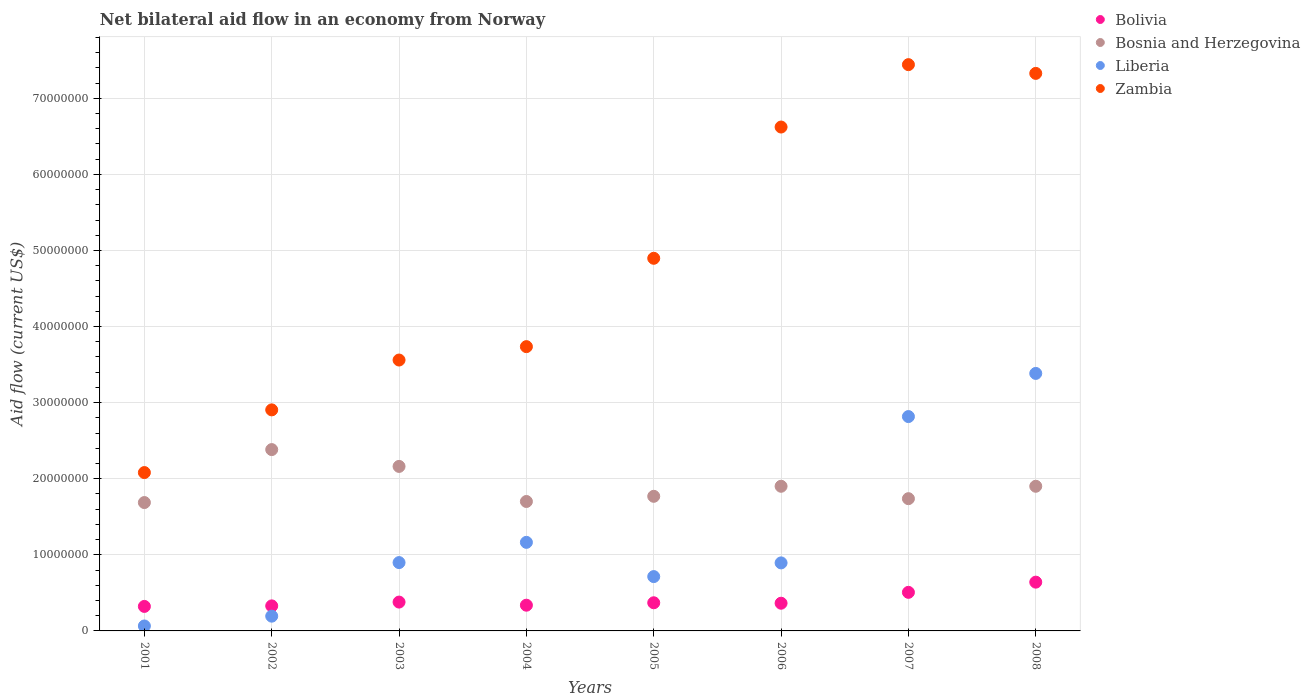Is the number of dotlines equal to the number of legend labels?
Your response must be concise. Yes. What is the net bilateral aid flow in Bolivia in 2003?
Provide a succinct answer. 3.79e+06. Across all years, what is the maximum net bilateral aid flow in Zambia?
Ensure brevity in your answer.  7.44e+07. Across all years, what is the minimum net bilateral aid flow in Bosnia and Herzegovina?
Provide a succinct answer. 1.69e+07. In which year was the net bilateral aid flow in Zambia maximum?
Offer a terse response. 2007. What is the total net bilateral aid flow in Bolivia in the graph?
Make the answer very short. 3.25e+07. What is the difference between the net bilateral aid flow in Bolivia in 2001 and that in 2008?
Provide a short and direct response. -3.19e+06. What is the difference between the net bilateral aid flow in Zambia in 2006 and the net bilateral aid flow in Bolivia in 2005?
Your response must be concise. 6.25e+07. What is the average net bilateral aid flow in Bosnia and Herzegovina per year?
Offer a very short reply. 1.91e+07. In the year 2003, what is the difference between the net bilateral aid flow in Bosnia and Herzegovina and net bilateral aid flow in Zambia?
Ensure brevity in your answer.  -1.40e+07. What is the ratio of the net bilateral aid flow in Zambia in 2001 to that in 2006?
Your answer should be compact. 0.31. Is the difference between the net bilateral aid flow in Bosnia and Herzegovina in 2001 and 2005 greater than the difference between the net bilateral aid flow in Zambia in 2001 and 2005?
Offer a terse response. Yes. What is the difference between the highest and the second highest net bilateral aid flow in Liberia?
Your response must be concise. 5.67e+06. What is the difference between the highest and the lowest net bilateral aid flow in Zambia?
Your response must be concise. 5.36e+07. In how many years, is the net bilateral aid flow in Bosnia and Herzegovina greater than the average net bilateral aid flow in Bosnia and Herzegovina taken over all years?
Keep it short and to the point. 2. Is it the case that in every year, the sum of the net bilateral aid flow in Zambia and net bilateral aid flow in Bolivia  is greater than the sum of net bilateral aid flow in Bosnia and Herzegovina and net bilateral aid flow in Liberia?
Your answer should be very brief. No. Is the net bilateral aid flow in Bosnia and Herzegovina strictly less than the net bilateral aid flow in Zambia over the years?
Ensure brevity in your answer.  Yes. Does the graph contain any zero values?
Provide a short and direct response. No. Where does the legend appear in the graph?
Provide a succinct answer. Top right. What is the title of the graph?
Provide a succinct answer. Net bilateral aid flow in an economy from Norway. Does "Congo (Democratic)" appear as one of the legend labels in the graph?
Provide a succinct answer. No. What is the label or title of the Y-axis?
Keep it short and to the point. Aid flow (current US$). What is the Aid flow (current US$) in Bolivia in 2001?
Give a very brief answer. 3.22e+06. What is the Aid flow (current US$) of Bosnia and Herzegovina in 2001?
Make the answer very short. 1.69e+07. What is the Aid flow (current US$) in Liberia in 2001?
Offer a very short reply. 6.50e+05. What is the Aid flow (current US$) in Zambia in 2001?
Give a very brief answer. 2.08e+07. What is the Aid flow (current US$) in Bolivia in 2002?
Make the answer very short. 3.29e+06. What is the Aid flow (current US$) in Bosnia and Herzegovina in 2002?
Make the answer very short. 2.38e+07. What is the Aid flow (current US$) of Liberia in 2002?
Your answer should be compact. 1.94e+06. What is the Aid flow (current US$) of Zambia in 2002?
Your answer should be compact. 2.90e+07. What is the Aid flow (current US$) of Bolivia in 2003?
Your answer should be very brief. 3.79e+06. What is the Aid flow (current US$) of Bosnia and Herzegovina in 2003?
Ensure brevity in your answer.  2.16e+07. What is the Aid flow (current US$) of Liberia in 2003?
Ensure brevity in your answer.  8.98e+06. What is the Aid flow (current US$) in Zambia in 2003?
Your response must be concise. 3.56e+07. What is the Aid flow (current US$) of Bolivia in 2004?
Your response must be concise. 3.38e+06. What is the Aid flow (current US$) in Bosnia and Herzegovina in 2004?
Your answer should be compact. 1.70e+07. What is the Aid flow (current US$) in Liberia in 2004?
Keep it short and to the point. 1.16e+07. What is the Aid flow (current US$) in Zambia in 2004?
Offer a very short reply. 3.74e+07. What is the Aid flow (current US$) in Bolivia in 2005?
Give a very brief answer. 3.70e+06. What is the Aid flow (current US$) in Bosnia and Herzegovina in 2005?
Keep it short and to the point. 1.77e+07. What is the Aid flow (current US$) of Liberia in 2005?
Give a very brief answer. 7.14e+06. What is the Aid flow (current US$) in Zambia in 2005?
Give a very brief answer. 4.90e+07. What is the Aid flow (current US$) of Bolivia in 2006?
Keep it short and to the point. 3.64e+06. What is the Aid flow (current US$) in Bosnia and Herzegovina in 2006?
Keep it short and to the point. 1.90e+07. What is the Aid flow (current US$) in Liberia in 2006?
Your response must be concise. 8.94e+06. What is the Aid flow (current US$) of Zambia in 2006?
Make the answer very short. 6.62e+07. What is the Aid flow (current US$) in Bolivia in 2007?
Keep it short and to the point. 5.07e+06. What is the Aid flow (current US$) in Bosnia and Herzegovina in 2007?
Your answer should be compact. 1.74e+07. What is the Aid flow (current US$) of Liberia in 2007?
Your answer should be compact. 2.82e+07. What is the Aid flow (current US$) of Zambia in 2007?
Ensure brevity in your answer.  7.44e+07. What is the Aid flow (current US$) of Bolivia in 2008?
Your response must be concise. 6.41e+06. What is the Aid flow (current US$) in Bosnia and Herzegovina in 2008?
Provide a short and direct response. 1.90e+07. What is the Aid flow (current US$) of Liberia in 2008?
Your answer should be compact. 3.38e+07. What is the Aid flow (current US$) of Zambia in 2008?
Offer a terse response. 7.33e+07. Across all years, what is the maximum Aid flow (current US$) in Bolivia?
Provide a short and direct response. 6.41e+06. Across all years, what is the maximum Aid flow (current US$) in Bosnia and Herzegovina?
Provide a short and direct response. 2.38e+07. Across all years, what is the maximum Aid flow (current US$) of Liberia?
Ensure brevity in your answer.  3.38e+07. Across all years, what is the maximum Aid flow (current US$) of Zambia?
Your answer should be very brief. 7.44e+07. Across all years, what is the minimum Aid flow (current US$) in Bolivia?
Your response must be concise. 3.22e+06. Across all years, what is the minimum Aid flow (current US$) in Bosnia and Herzegovina?
Your answer should be very brief. 1.69e+07. Across all years, what is the minimum Aid flow (current US$) of Liberia?
Provide a short and direct response. 6.50e+05. Across all years, what is the minimum Aid flow (current US$) of Zambia?
Provide a succinct answer. 2.08e+07. What is the total Aid flow (current US$) of Bolivia in the graph?
Keep it short and to the point. 3.25e+07. What is the total Aid flow (current US$) in Bosnia and Herzegovina in the graph?
Your answer should be very brief. 1.52e+08. What is the total Aid flow (current US$) of Liberia in the graph?
Your answer should be compact. 1.01e+08. What is the total Aid flow (current US$) of Zambia in the graph?
Give a very brief answer. 3.86e+08. What is the difference between the Aid flow (current US$) of Bolivia in 2001 and that in 2002?
Provide a short and direct response. -7.00e+04. What is the difference between the Aid flow (current US$) of Bosnia and Herzegovina in 2001 and that in 2002?
Keep it short and to the point. -6.96e+06. What is the difference between the Aid flow (current US$) of Liberia in 2001 and that in 2002?
Ensure brevity in your answer.  -1.29e+06. What is the difference between the Aid flow (current US$) in Zambia in 2001 and that in 2002?
Make the answer very short. -8.24e+06. What is the difference between the Aid flow (current US$) of Bolivia in 2001 and that in 2003?
Keep it short and to the point. -5.70e+05. What is the difference between the Aid flow (current US$) in Bosnia and Herzegovina in 2001 and that in 2003?
Your answer should be compact. -4.75e+06. What is the difference between the Aid flow (current US$) in Liberia in 2001 and that in 2003?
Provide a short and direct response. -8.33e+06. What is the difference between the Aid flow (current US$) in Zambia in 2001 and that in 2003?
Your response must be concise. -1.48e+07. What is the difference between the Aid flow (current US$) in Bosnia and Herzegovina in 2001 and that in 2004?
Make the answer very short. -1.40e+05. What is the difference between the Aid flow (current US$) of Liberia in 2001 and that in 2004?
Your answer should be compact. -1.10e+07. What is the difference between the Aid flow (current US$) of Zambia in 2001 and that in 2004?
Your answer should be very brief. -1.66e+07. What is the difference between the Aid flow (current US$) of Bolivia in 2001 and that in 2005?
Offer a very short reply. -4.80e+05. What is the difference between the Aid flow (current US$) of Bosnia and Herzegovina in 2001 and that in 2005?
Your answer should be compact. -8.20e+05. What is the difference between the Aid flow (current US$) in Liberia in 2001 and that in 2005?
Your response must be concise. -6.49e+06. What is the difference between the Aid flow (current US$) of Zambia in 2001 and that in 2005?
Give a very brief answer. -2.82e+07. What is the difference between the Aid flow (current US$) of Bolivia in 2001 and that in 2006?
Your answer should be very brief. -4.20e+05. What is the difference between the Aid flow (current US$) in Bosnia and Herzegovina in 2001 and that in 2006?
Your response must be concise. -2.14e+06. What is the difference between the Aid flow (current US$) in Liberia in 2001 and that in 2006?
Offer a very short reply. -8.29e+06. What is the difference between the Aid flow (current US$) in Zambia in 2001 and that in 2006?
Your answer should be compact. -4.54e+07. What is the difference between the Aid flow (current US$) of Bolivia in 2001 and that in 2007?
Your answer should be compact. -1.85e+06. What is the difference between the Aid flow (current US$) of Bosnia and Herzegovina in 2001 and that in 2007?
Offer a terse response. -5.10e+05. What is the difference between the Aid flow (current US$) of Liberia in 2001 and that in 2007?
Your answer should be very brief. -2.75e+07. What is the difference between the Aid flow (current US$) of Zambia in 2001 and that in 2007?
Offer a terse response. -5.36e+07. What is the difference between the Aid flow (current US$) of Bolivia in 2001 and that in 2008?
Offer a very short reply. -3.19e+06. What is the difference between the Aid flow (current US$) in Bosnia and Herzegovina in 2001 and that in 2008?
Your answer should be very brief. -2.14e+06. What is the difference between the Aid flow (current US$) of Liberia in 2001 and that in 2008?
Provide a short and direct response. -3.32e+07. What is the difference between the Aid flow (current US$) in Zambia in 2001 and that in 2008?
Make the answer very short. -5.25e+07. What is the difference between the Aid flow (current US$) in Bolivia in 2002 and that in 2003?
Keep it short and to the point. -5.00e+05. What is the difference between the Aid flow (current US$) in Bosnia and Herzegovina in 2002 and that in 2003?
Give a very brief answer. 2.21e+06. What is the difference between the Aid flow (current US$) in Liberia in 2002 and that in 2003?
Your answer should be compact. -7.04e+06. What is the difference between the Aid flow (current US$) in Zambia in 2002 and that in 2003?
Ensure brevity in your answer.  -6.55e+06. What is the difference between the Aid flow (current US$) in Bolivia in 2002 and that in 2004?
Give a very brief answer. -9.00e+04. What is the difference between the Aid flow (current US$) of Bosnia and Herzegovina in 2002 and that in 2004?
Provide a succinct answer. 6.82e+06. What is the difference between the Aid flow (current US$) in Liberia in 2002 and that in 2004?
Provide a short and direct response. -9.70e+06. What is the difference between the Aid flow (current US$) in Zambia in 2002 and that in 2004?
Give a very brief answer. -8.31e+06. What is the difference between the Aid flow (current US$) in Bolivia in 2002 and that in 2005?
Provide a succinct answer. -4.10e+05. What is the difference between the Aid flow (current US$) in Bosnia and Herzegovina in 2002 and that in 2005?
Give a very brief answer. 6.14e+06. What is the difference between the Aid flow (current US$) in Liberia in 2002 and that in 2005?
Ensure brevity in your answer.  -5.20e+06. What is the difference between the Aid flow (current US$) in Zambia in 2002 and that in 2005?
Make the answer very short. -1.99e+07. What is the difference between the Aid flow (current US$) in Bolivia in 2002 and that in 2006?
Give a very brief answer. -3.50e+05. What is the difference between the Aid flow (current US$) in Bosnia and Herzegovina in 2002 and that in 2006?
Offer a terse response. 4.82e+06. What is the difference between the Aid flow (current US$) in Liberia in 2002 and that in 2006?
Keep it short and to the point. -7.00e+06. What is the difference between the Aid flow (current US$) of Zambia in 2002 and that in 2006?
Give a very brief answer. -3.72e+07. What is the difference between the Aid flow (current US$) of Bolivia in 2002 and that in 2007?
Offer a very short reply. -1.78e+06. What is the difference between the Aid flow (current US$) in Bosnia and Herzegovina in 2002 and that in 2007?
Provide a succinct answer. 6.45e+06. What is the difference between the Aid flow (current US$) of Liberia in 2002 and that in 2007?
Offer a very short reply. -2.62e+07. What is the difference between the Aid flow (current US$) of Zambia in 2002 and that in 2007?
Your response must be concise. -4.54e+07. What is the difference between the Aid flow (current US$) of Bolivia in 2002 and that in 2008?
Ensure brevity in your answer.  -3.12e+06. What is the difference between the Aid flow (current US$) in Bosnia and Herzegovina in 2002 and that in 2008?
Offer a very short reply. 4.82e+06. What is the difference between the Aid flow (current US$) of Liberia in 2002 and that in 2008?
Give a very brief answer. -3.19e+07. What is the difference between the Aid flow (current US$) in Zambia in 2002 and that in 2008?
Provide a short and direct response. -4.42e+07. What is the difference between the Aid flow (current US$) of Bosnia and Herzegovina in 2003 and that in 2004?
Ensure brevity in your answer.  4.61e+06. What is the difference between the Aid flow (current US$) in Liberia in 2003 and that in 2004?
Make the answer very short. -2.66e+06. What is the difference between the Aid flow (current US$) in Zambia in 2003 and that in 2004?
Keep it short and to the point. -1.76e+06. What is the difference between the Aid flow (current US$) of Bosnia and Herzegovina in 2003 and that in 2005?
Give a very brief answer. 3.93e+06. What is the difference between the Aid flow (current US$) in Liberia in 2003 and that in 2005?
Provide a short and direct response. 1.84e+06. What is the difference between the Aid flow (current US$) in Zambia in 2003 and that in 2005?
Make the answer very short. -1.34e+07. What is the difference between the Aid flow (current US$) of Bolivia in 2003 and that in 2006?
Make the answer very short. 1.50e+05. What is the difference between the Aid flow (current US$) of Bosnia and Herzegovina in 2003 and that in 2006?
Offer a terse response. 2.61e+06. What is the difference between the Aid flow (current US$) of Liberia in 2003 and that in 2006?
Your answer should be very brief. 4.00e+04. What is the difference between the Aid flow (current US$) of Zambia in 2003 and that in 2006?
Keep it short and to the point. -3.06e+07. What is the difference between the Aid flow (current US$) in Bolivia in 2003 and that in 2007?
Make the answer very short. -1.28e+06. What is the difference between the Aid flow (current US$) of Bosnia and Herzegovina in 2003 and that in 2007?
Make the answer very short. 4.24e+06. What is the difference between the Aid flow (current US$) in Liberia in 2003 and that in 2007?
Provide a short and direct response. -1.92e+07. What is the difference between the Aid flow (current US$) of Zambia in 2003 and that in 2007?
Give a very brief answer. -3.88e+07. What is the difference between the Aid flow (current US$) in Bolivia in 2003 and that in 2008?
Make the answer very short. -2.62e+06. What is the difference between the Aid flow (current US$) in Bosnia and Herzegovina in 2003 and that in 2008?
Provide a short and direct response. 2.61e+06. What is the difference between the Aid flow (current US$) of Liberia in 2003 and that in 2008?
Provide a succinct answer. -2.49e+07. What is the difference between the Aid flow (current US$) in Zambia in 2003 and that in 2008?
Provide a short and direct response. -3.77e+07. What is the difference between the Aid flow (current US$) of Bolivia in 2004 and that in 2005?
Your answer should be very brief. -3.20e+05. What is the difference between the Aid flow (current US$) in Bosnia and Herzegovina in 2004 and that in 2005?
Your answer should be very brief. -6.80e+05. What is the difference between the Aid flow (current US$) of Liberia in 2004 and that in 2005?
Give a very brief answer. 4.50e+06. What is the difference between the Aid flow (current US$) in Zambia in 2004 and that in 2005?
Provide a succinct answer. -1.16e+07. What is the difference between the Aid flow (current US$) in Bolivia in 2004 and that in 2006?
Provide a short and direct response. -2.60e+05. What is the difference between the Aid flow (current US$) of Liberia in 2004 and that in 2006?
Keep it short and to the point. 2.70e+06. What is the difference between the Aid flow (current US$) of Zambia in 2004 and that in 2006?
Your response must be concise. -2.89e+07. What is the difference between the Aid flow (current US$) of Bolivia in 2004 and that in 2007?
Give a very brief answer. -1.69e+06. What is the difference between the Aid flow (current US$) of Bosnia and Herzegovina in 2004 and that in 2007?
Your response must be concise. -3.70e+05. What is the difference between the Aid flow (current US$) in Liberia in 2004 and that in 2007?
Offer a very short reply. -1.65e+07. What is the difference between the Aid flow (current US$) of Zambia in 2004 and that in 2007?
Provide a short and direct response. -3.71e+07. What is the difference between the Aid flow (current US$) in Bolivia in 2004 and that in 2008?
Your answer should be very brief. -3.03e+06. What is the difference between the Aid flow (current US$) in Bosnia and Herzegovina in 2004 and that in 2008?
Make the answer very short. -2.00e+06. What is the difference between the Aid flow (current US$) of Liberia in 2004 and that in 2008?
Provide a short and direct response. -2.22e+07. What is the difference between the Aid flow (current US$) in Zambia in 2004 and that in 2008?
Offer a terse response. -3.59e+07. What is the difference between the Aid flow (current US$) of Bosnia and Herzegovina in 2005 and that in 2006?
Offer a terse response. -1.32e+06. What is the difference between the Aid flow (current US$) of Liberia in 2005 and that in 2006?
Give a very brief answer. -1.80e+06. What is the difference between the Aid flow (current US$) in Zambia in 2005 and that in 2006?
Your response must be concise. -1.72e+07. What is the difference between the Aid flow (current US$) of Bolivia in 2005 and that in 2007?
Your response must be concise. -1.37e+06. What is the difference between the Aid flow (current US$) in Liberia in 2005 and that in 2007?
Make the answer very short. -2.10e+07. What is the difference between the Aid flow (current US$) of Zambia in 2005 and that in 2007?
Your response must be concise. -2.54e+07. What is the difference between the Aid flow (current US$) of Bolivia in 2005 and that in 2008?
Offer a terse response. -2.71e+06. What is the difference between the Aid flow (current US$) of Bosnia and Herzegovina in 2005 and that in 2008?
Your response must be concise. -1.32e+06. What is the difference between the Aid flow (current US$) of Liberia in 2005 and that in 2008?
Give a very brief answer. -2.67e+07. What is the difference between the Aid flow (current US$) in Zambia in 2005 and that in 2008?
Keep it short and to the point. -2.43e+07. What is the difference between the Aid flow (current US$) of Bolivia in 2006 and that in 2007?
Keep it short and to the point. -1.43e+06. What is the difference between the Aid flow (current US$) in Bosnia and Herzegovina in 2006 and that in 2007?
Offer a very short reply. 1.63e+06. What is the difference between the Aid flow (current US$) in Liberia in 2006 and that in 2007?
Provide a short and direct response. -1.92e+07. What is the difference between the Aid flow (current US$) in Zambia in 2006 and that in 2007?
Make the answer very short. -8.20e+06. What is the difference between the Aid flow (current US$) in Bolivia in 2006 and that in 2008?
Your answer should be compact. -2.77e+06. What is the difference between the Aid flow (current US$) in Liberia in 2006 and that in 2008?
Keep it short and to the point. -2.49e+07. What is the difference between the Aid flow (current US$) of Zambia in 2006 and that in 2008?
Offer a very short reply. -7.05e+06. What is the difference between the Aid flow (current US$) in Bolivia in 2007 and that in 2008?
Provide a succinct answer. -1.34e+06. What is the difference between the Aid flow (current US$) in Bosnia and Herzegovina in 2007 and that in 2008?
Make the answer very short. -1.63e+06. What is the difference between the Aid flow (current US$) of Liberia in 2007 and that in 2008?
Offer a very short reply. -5.67e+06. What is the difference between the Aid flow (current US$) in Zambia in 2007 and that in 2008?
Give a very brief answer. 1.15e+06. What is the difference between the Aid flow (current US$) of Bolivia in 2001 and the Aid flow (current US$) of Bosnia and Herzegovina in 2002?
Offer a very short reply. -2.06e+07. What is the difference between the Aid flow (current US$) of Bolivia in 2001 and the Aid flow (current US$) of Liberia in 2002?
Your answer should be very brief. 1.28e+06. What is the difference between the Aid flow (current US$) of Bolivia in 2001 and the Aid flow (current US$) of Zambia in 2002?
Provide a succinct answer. -2.58e+07. What is the difference between the Aid flow (current US$) in Bosnia and Herzegovina in 2001 and the Aid flow (current US$) in Liberia in 2002?
Provide a short and direct response. 1.49e+07. What is the difference between the Aid flow (current US$) of Bosnia and Herzegovina in 2001 and the Aid flow (current US$) of Zambia in 2002?
Provide a succinct answer. -1.22e+07. What is the difference between the Aid flow (current US$) in Liberia in 2001 and the Aid flow (current US$) in Zambia in 2002?
Offer a very short reply. -2.84e+07. What is the difference between the Aid flow (current US$) in Bolivia in 2001 and the Aid flow (current US$) in Bosnia and Herzegovina in 2003?
Keep it short and to the point. -1.84e+07. What is the difference between the Aid flow (current US$) in Bolivia in 2001 and the Aid flow (current US$) in Liberia in 2003?
Ensure brevity in your answer.  -5.76e+06. What is the difference between the Aid flow (current US$) of Bolivia in 2001 and the Aid flow (current US$) of Zambia in 2003?
Your answer should be compact. -3.24e+07. What is the difference between the Aid flow (current US$) in Bosnia and Herzegovina in 2001 and the Aid flow (current US$) in Liberia in 2003?
Keep it short and to the point. 7.89e+06. What is the difference between the Aid flow (current US$) of Bosnia and Herzegovina in 2001 and the Aid flow (current US$) of Zambia in 2003?
Make the answer very short. -1.87e+07. What is the difference between the Aid flow (current US$) in Liberia in 2001 and the Aid flow (current US$) in Zambia in 2003?
Provide a short and direct response. -3.50e+07. What is the difference between the Aid flow (current US$) of Bolivia in 2001 and the Aid flow (current US$) of Bosnia and Herzegovina in 2004?
Provide a succinct answer. -1.38e+07. What is the difference between the Aid flow (current US$) of Bolivia in 2001 and the Aid flow (current US$) of Liberia in 2004?
Your answer should be very brief. -8.42e+06. What is the difference between the Aid flow (current US$) in Bolivia in 2001 and the Aid flow (current US$) in Zambia in 2004?
Make the answer very short. -3.41e+07. What is the difference between the Aid flow (current US$) in Bosnia and Herzegovina in 2001 and the Aid flow (current US$) in Liberia in 2004?
Offer a terse response. 5.23e+06. What is the difference between the Aid flow (current US$) of Bosnia and Herzegovina in 2001 and the Aid flow (current US$) of Zambia in 2004?
Give a very brief answer. -2.05e+07. What is the difference between the Aid flow (current US$) in Liberia in 2001 and the Aid flow (current US$) in Zambia in 2004?
Your response must be concise. -3.67e+07. What is the difference between the Aid flow (current US$) in Bolivia in 2001 and the Aid flow (current US$) in Bosnia and Herzegovina in 2005?
Make the answer very short. -1.45e+07. What is the difference between the Aid flow (current US$) in Bolivia in 2001 and the Aid flow (current US$) in Liberia in 2005?
Provide a short and direct response. -3.92e+06. What is the difference between the Aid flow (current US$) of Bolivia in 2001 and the Aid flow (current US$) of Zambia in 2005?
Offer a terse response. -4.58e+07. What is the difference between the Aid flow (current US$) in Bosnia and Herzegovina in 2001 and the Aid flow (current US$) in Liberia in 2005?
Keep it short and to the point. 9.73e+06. What is the difference between the Aid flow (current US$) of Bosnia and Herzegovina in 2001 and the Aid flow (current US$) of Zambia in 2005?
Keep it short and to the point. -3.21e+07. What is the difference between the Aid flow (current US$) in Liberia in 2001 and the Aid flow (current US$) in Zambia in 2005?
Your answer should be compact. -4.83e+07. What is the difference between the Aid flow (current US$) in Bolivia in 2001 and the Aid flow (current US$) in Bosnia and Herzegovina in 2006?
Your answer should be compact. -1.58e+07. What is the difference between the Aid flow (current US$) in Bolivia in 2001 and the Aid flow (current US$) in Liberia in 2006?
Your response must be concise. -5.72e+06. What is the difference between the Aid flow (current US$) of Bolivia in 2001 and the Aid flow (current US$) of Zambia in 2006?
Your answer should be very brief. -6.30e+07. What is the difference between the Aid flow (current US$) of Bosnia and Herzegovina in 2001 and the Aid flow (current US$) of Liberia in 2006?
Offer a terse response. 7.93e+06. What is the difference between the Aid flow (current US$) of Bosnia and Herzegovina in 2001 and the Aid flow (current US$) of Zambia in 2006?
Offer a very short reply. -4.94e+07. What is the difference between the Aid flow (current US$) in Liberia in 2001 and the Aid flow (current US$) in Zambia in 2006?
Make the answer very short. -6.56e+07. What is the difference between the Aid flow (current US$) in Bolivia in 2001 and the Aid flow (current US$) in Bosnia and Herzegovina in 2007?
Your answer should be compact. -1.42e+07. What is the difference between the Aid flow (current US$) in Bolivia in 2001 and the Aid flow (current US$) in Liberia in 2007?
Offer a terse response. -2.50e+07. What is the difference between the Aid flow (current US$) in Bolivia in 2001 and the Aid flow (current US$) in Zambia in 2007?
Offer a terse response. -7.12e+07. What is the difference between the Aid flow (current US$) in Bosnia and Herzegovina in 2001 and the Aid flow (current US$) in Liberia in 2007?
Your response must be concise. -1.13e+07. What is the difference between the Aid flow (current US$) in Bosnia and Herzegovina in 2001 and the Aid flow (current US$) in Zambia in 2007?
Make the answer very short. -5.76e+07. What is the difference between the Aid flow (current US$) in Liberia in 2001 and the Aid flow (current US$) in Zambia in 2007?
Keep it short and to the point. -7.38e+07. What is the difference between the Aid flow (current US$) in Bolivia in 2001 and the Aid flow (current US$) in Bosnia and Herzegovina in 2008?
Provide a succinct answer. -1.58e+07. What is the difference between the Aid flow (current US$) of Bolivia in 2001 and the Aid flow (current US$) of Liberia in 2008?
Provide a short and direct response. -3.06e+07. What is the difference between the Aid flow (current US$) of Bolivia in 2001 and the Aid flow (current US$) of Zambia in 2008?
Offer a very short reply. -7.00e+07. What is the difference between the Aid flow (current US$) in Bosnia and Herzegovina in 2001 and the Aid flow (current US$) in Liberia in 2008?
Provide a short and direct response. -1.70e+07. What is the difference between the Aid flow (current US$) of Bosnia and Herzegovina in 2001 and the Aid flow (current US$) of Zambia in 2008?
Ensure brevity in your answer.  -5.64e+07. What is the difference between the Aid flow (current US$) of Liberia in 2001 and the Aid flow (current US$) of Zambia in 2008?
Your response must be concise. -7.26e+07. What is the difference between the Aid flow (current US$) of Bolivia in 2002 and the Aid flow (current US$) of Bosnia and Herzegovina in 2003?
Ensure brevity in your answer.  -1.83e+07. What is the difference between the Aid flow (current US$) in Bolivia in 2002 and the Aid flow (current US$) in Liberia in 2003?
Give a very brief answer. -5.69e+06. What is the difference between the Aid flow (current US$) in Bolivia in 2002 and the Aid flow (current US$) in Zambia in 2003?
Offer a terse response. -3.23e+07. What is the difference between the Aid flow (current US$) of Bosnia and Herzegovina in 2002 and the Aid flow (current US$) of Liberia in 2003?
Your answer should be very brief. 1.48e+07. What is the difference between the Aid flow (current US$) of Bosnia and Herzegovina in 2002 and the Aid flow (current US$) of Zambia in 2003?
Give a very brief answer. -1.18e+07. What is the difference between the Aid flow (current US$) of Liberia in 2002 and the Aid flow (current US$) of Zambia in 2003?
Give a very brief answer. -3.37e+07. What is the difference between the Aid flow (current US$) of Bolivia in 2002 and the Aid flow (current US$) of Bosnia and Herzegovina in 2004?
Your answer should be very brief. -1.37e+07. What is the difference between the Aid flow (current US$) of Bolivia in 2002 and the Aid flow (current US$) of Liberia in 2004?
Ensure brevity in your answer.  -8.35e+06. What is the difference between the Aid flow (current US$) in Bolivia in 2002 and the Aid flow (current US$) in Zambia in 2004?
Offer a very short reply. -3.41e+07. What is the difference between the Aid flow (current US$) of Bosnia and Herzegovina in 2002 and the Aid flow (current US$) of Liberia in 2004?
Provide a succinct answer. 1.22e+07. What is the difference between the Aid flow (current US$) of Bosnia and Herzegovina in 2002 and the Aid flow (current US$) of Zambia in 2004?
Your answer should be very brief. -1.35e+07. What is the difference between the Aid flow (current US$) in Liberia in 2002 and the Aid flow (current US$) in Zambia in 2004?
Offer a terse response. -3.54e+07. What is the difference between the Aid flow (current US$) in Bolivia in 2002 and the Aid flow (current US$) in Bosnia and Herzegovina in 2005?
Ensure brevity in your answer.  -1.44e+07. What is the difference between the Aid flow (current US$) in Bolivia in 2002 and the Aid flow (current US$) in Liberia in 2005?
Your answer should be compact. -3.85e+06. What is the difference between the Aid flow (current US$) of Bolivia in 2002 and the Aid flow (current US$) of Zambia in 2005?
Make the answer very short. -4.57e+07. What is the difference between the Aid flow (current US$) in Bosnia and Herzegovina in 2002 and the Aid flow (current US$) in Liberia in 2005?
Your response must be concise. 1.67e+07. What is the difference between the Aid flow (current US$) in Bosnia and Herzegovina in 2002 and the Aid flow (current US$) in Zambia in 2005?
Ensure brevity in your answer.  -2.51e+07. What is the difference between the Aid flow (current US$) of Liberia in 2002 and the Aid flow (current US$) of Zambia in 2005?
Provide a succinct answer. -4.70e+07. What is the difference between the Aid flow (current US$) of Bolivia in 2002 and the Aid flow (current US$) of Bosnia and Herzegovina in 2006?
Your answer should be very brief. -1.57e+07. What is the difference between the Aid flow (current US$) of Bolivia in 2002 and the Aid flow (current US$) of Liberia in 2006?
Provide a short and direct response. -5.65e+06. What is the difference between the Aid flow (current US$) of Bolivia in 2002 and the Aid flow (current US$) of Zambia in 2006?
Give a very brief answer. -6.29e+07. What is the difference between the Aid flow (current US$) in Bosnia and Herzegovina in 2002 and the Aid flow (current US$) in Liberia in 2006?
Ensure brevity in your answer.  1.49e+07. What is the difference between the Aid flow (current US$) of Bosnia and Herzegovina in 2002 and the Aid flow (current US$) of Zambia in 2006?
Your answer should be very brief. -4.24e+07. What is the difference between the Aid flow (current US$) in Liberia in 2002 and the Aid flow (current US$) in Zambia in 2006?
Provide a short and direct response. -6.43e+07. What is the difference between the Aid flow (current US$) in Bolivia in 2002 and the Aid flow (current US$) in Bosnia and Herzegovina in 2007?
Your answer should be compact. -1.41e+07. What is the difference between the Aid flow (current US$) in Bolivia in 2002 and the Aid flow (current US$) in Liberia in 2007?
Your response must be concise. -2.49e+07. What is the difference between the Aid flow (current US$) of Bolivia in 2002 and the Aid flow (current US$) of Zambia in 2007?
Keep it short and to the point. -7.11e+07. What is the difference between the Aid flow (current US$) of Bosnia and Herzegovina in 2002 and the Aid flow (current US$) of Liberia in 2007?
Offer a very short reply. -4.34e+06. What is the difference between the Aid flow (current US$) of Bosnia and Herzegovina in 2002 and the Aid flow (current US$) of Zambia in 2007?
Keep it short and to the point. -5.06e+07. What is the difference between the Aid flow (current US$) of Liberia in 2002 and the Aid flow (current US$) of Zambia in 2007?
Provide a short and direct response. -7.25e+07. What is the difference between the Aid flow (current US$) in Bolivia in 2002 and the Aid flow (current US$) in Bosnia and Herzegovina in 2008?
Keep it short and to the point. -1.57e+07. What is the difference between the Aid flow (current US$) in Bolivia in 2002 and the Aid flow (current US$) in Liberia in 2008?
Your answer should be compact. -3.06e+07. What is the difference between the Aid flow (current US$) of Bolivia in 2002 and the Aid flow (current US$) of Zambia in 2008?
Give a very brief answer. -7.00e+07. What is the difference between the Aid flow (current US$) in Bosnia and Herzegovina in 2002 and the Aid flow (current US$) in Liberia in 2008?
Keep it short and to the point. -1.00e+07. What is the difference between the Aid flow (current US$) of Bosnia and Herzegovina in 2002 and the Aid flow (current US$) of Zambia in 2008?
Provide a short and direct response. -4.94e+07. What is the difference between the Aid flow (current US$) of Liberia in 2002 and the Aid flow (current US$) of Zambia in 2008?
Your response must be concise. -7.13e+07. What is the difference between the Aid flow (current US$) of Bolivia in 2003 and the Aid flow (current US$) of Bosnia and Herzegovina in 2004?
Your answer should be very brief. -1.32e+07. What is the difference between the Aid flow (current US$) in Bolivia in 2003 and the Aid flow (current US$) in Liberia in 2004?
Offer a very short reply. -7.85e+06. What is the difference between the Aid flow (current US$) of Bolivia in 2003 and the Aid flow (current US$) of Zambia in 2004?
Provide a succinct answer. -3.36e+07. What is the difference between the Aid flow (current US$) in Bosnia and Herzegovina in 2003 and the Aid flow (current US$) in Liberia in 2004?
Your answer should be very brief. 9.98e+06. What is the difference between the Aid flow (current US$) of Bosnia and Herzegovina in 2003 and the Aid flow (current US$) of Zambia in 2004?
Your answer should be very brief. -1.57e+07. What is the difference between the Aid flow (current US$) in Liberia in 2003 and the Aid flow (current US$) in Zambia in 2004?
Offer a terse response. -2.84e+07. What is the difference between the Aid flow (current US$) of Bolivia in 2003 and the Aid flow (current US$) of Bosnia and Herzegovina in 2005?
Offer a very short reply. -1.39e+07. What is the difference between the Aid flow (current US$) of Bolivia in 2003 and the Aid flow (current US$) of Liberia in 2005?
Your response must be concise. -3.35e+06. What is the difference between the Aid flow (current US$) of Bolivia in 2003 and the Aid flow (current US$) of Zambia in 2005?
Ensure brevity in your answer.  -4.52e+07. What is the difference between the Aid flow (current US$) in Bosnia and Herzegovina in 2003 and the Aid flow (current US$) in Liberia in 2005?
Your response must be concise. 1.45e+07. What is the difference between the Aid flow (current US$) in Bosnia and Herzegovina in 2003 and the Aid flow (current US$) in Zambia in 2005?
Keep it short and to the point. -2.74e+07. What is the difference between the Aid flow (current US$) of Liberia in 2003 and the Aid flow (current US$) of Zambia in 2005?
Offer a very short reply. -4.00e+07. What is the difference between the Aid flow (current US$) in Bolivia in 2003 and the Aid flow (current US$) in Bosnia and Herzegovina in 2006?
Your response must be concise. -1.52e+07. What is the difference between the Aid flow (current US$) in Bolivia in 2003 and the Aid flow (current US$) in Liberia in 2006?
Provide a short and direct response. -5.15e+06. What is the difference between the Aid flow (current US$) of Bolivia in 2003 and the Aid flow (current US$) of Zambia in 2006?
Your answer should be compact. -6.24e+07. What is the difference between the Aid flow (current US$) in Bosnia and Herzegovina in 2003 and the Aid flow (current US$) in Liberia in 2006?
Make the answer very short. 1.27e+07. What is the difference between the Aid flow (current US$) in Bosnia and Herzegovina in 2003 and the Aid flow (current US$) in Zambia in 2006?
Provide a short and direct response. -4.46e+07. What is the difference between the Aid flow (current US$) of Liberia in 2003 and the Aid flow (current US$) of Zambia in 2006?
Provide a succinct answer. -5.72e+07. What is the difference between the Aid flow (current US$) in Bolivia in 2003 and the Aid flow (current US$) in Bosnia and Herzegovina in 2007?
Provide a short and direct response. -1.36e+07. What is the difference between the Aid flow (current US$) in Bolivia in 2003 and the Aid flow (current US$) in Liberia in 2007?
Your answer should be compact. -2.44e+07. What is the difference between the Aid flow (current US$) of Bolivia in 2003 and the Aid flow (current US$) of Zambia in 2007?
Give a very brief answer. -7.06e+07. What is the difference between the Aid flow (current US$) of Bosnia and Herzegovina in 2003 and the Aid flow (current US$) of Liberia in 2007?
Your response must be concise. -6.55e+06. What is the difference between the Aid flow (current US$) in Bosnia and Herzegovina in 2003 and the Aid flow (current US$) in Zambia in 2007?
Keep it short and to the point. -5.28e+07. What is the difference between the Aid flow (current US$) of Liberia in 2003 and the Aid flow (current US$) of Zambia in 2007?
Make the answer very short. -6.54e+07. What is the difference between the Aid flow (current US$) in Bolivia in 2003 and the Aid flow (current US$) in Bosnia and Herzegovina in 2008?
Provide a succinct answer. -1.52e+07. What is the difference between the Aid flow (current US$) in Bolivia in 2003 and the Aid flow (current US$) in Liberia in 2008?
Make the answer very short. -3.00e+07. What is the difference between the Aid flow (current US$) of Bolivia in 2003 and the Aid flow (current US$) of Zambia in 2008?
Your answer should be very brief. -6.95e+07. What is the difference between the Aid flow (current US$) of Bosnia and Herzegovina in 2003 and the Aid flow (current US$) of Liberia in 2008?
Provide a short and direct response. -1.22e+07. What is the difference between the Aid flow (current US$) in Bosnia and Herzegovina in 2003 and the Aid flow (current US$) in Zambia in 2008?
Keep it short and to the point. -5.16e+07. What is the difference between the Aid flow (current US$) in Liberia in 2003 and the Aid flow (current US$) in Zambia in 2008?
Ensure brevity in your answer.  -6.43e+07. What is the difference between the Aid flow (current US$) in Bolivia in 2004 and the Aid flow (current US$) in Bosnia and Herzegovina in 2005?
Keep it short and to the point. -1.43e+07. What is the difference between the Aid flow (current US$) in Bolivia in 2004 and the Aid flow (current US$) in Liberia in 2005?
Your response must be concise. -3.76e+06. What is the difference between the Aid flow (current US$) of Bolivia in 2004 and the Aid flow (current US$) of Zambia in 2005?
Your answer should be very brief. -4.56e+07. What is the difference between the Aid flow (current US$) of Bosnia and Herzegovina in 2004 and the Aid flow (current US$) of Liberia in 2005?
Your answer should be compact. 9.87e+06. What is the difference between the Aid flow (current US$) in Bosnia and Herzegovina in 2004 and the Aid flow (current US$) in Zambia in 2005?
Give a very brief answer. -3.20e+07. What is the difference between the Aid flow (current US$) of Liberia in 2004 and the Aid flow (current US$) of Zambia in 2005?
Provide a short and direct response. -3.73e+07. What is the difference between the Aid flow (current US$) in Bolivia in 2004 and the Aid flow (current US$) in Bosnia and Herzegovina in 2006?
Ensure brevity in your answer.  -1.56e+07. What is the difference between the Aid flow (current US$) in Bolivia in 2004 and the Aid flow (current US$) in Liberia in 2006?
Your answer should be very brief. -5.56e+06. What is the difference between the Aid flow (current US$) in Bolivia in 2004 and the Aid flow (current US$) in Zambia in 2006?
Your answer should be compact. -6.28e+07. What is the difference between the Aid flow (current US$) in Bosnia and Herzegovina in 2004 and the Aid flow (current US$) in Liberia in 2006?
Offer a terse response. 8.07e+06. What is the difference between the Aid flow (current US$) of Bosnia and Herzegovina in 2004 and the Aid flow (current US$) of Zambia in 2006?
Offer a terse response. -4.92e+07. What is the difference between the Aid flow (current US$) of Liberia in 2004 and the Aid flow (current US$) of Zambia in 2006?
Give a very brief answer. -5.46e+07. What is the difference between the Aid flow (current US$) in Bolivia in 2004 and the Aid flow (current US$) in Bosnia and Herzegovina in 2007?
Provide a short and direct response. -1.40e+07. What is the difference between the Aid flow (current US$) of Bolivia in 2004 and the Aid flow (current US$) of Liberia in 2007?
Offer a terse response. -2.48e+07. What is the difference between the Aid flow (current US$) of Bolivia in 2004 and the Aid flow (current US$) of Zambia in 2007?
Your response must be concise. -7.10e+07. What is the difference between the Aid flow (current US$) in Bosnia and Herzegovina in 2004 and the Aid flow (current US$) in Liberia in 2007?
Keep it short and to the point. -1.12e+07. What is the difference between the Aid flow (current US$) in Bosnia and Herzegovina in 2004 and the Aid flow (current US$) in Zambia in 2007?
Ensure brevity in your answer.  -5.74e+07. What is the difference between the Aid flow (current US$) in Liberia in 2004 and the Aid flow (current US$) in Zambia in 2007?
Offer a very short reply. -6.28e+07. What is the difference between the Aid flow (current US$) in Bolivia in 2004 and the Aid flow (current US$) in Bosnia and Herzegovina in 2008?
Keep it short and to the point. -1.56e+07. What is the difference between the Aid flow (current US$) in Bolivia in 2004 and the Aid flow (current US$) in Liberia in 2008?
Offer a very short reply. -3.05e+07. What is the difference between the Aid flow (current US$) in Bolivia in 2004 and the Aid flow (current US$) in Zambia in 2008?
Your answer should be compact. -6.99e+07. What is the difference between the Aid flow (current US$) in Bosnia and Herzegovina in 2004 and the Aid flow (current US$) in Liberia in 2008?
Provide a short and direct response. -1.68e+07. What is the difference between the Aid flow (current US$) in Bosnia and Herzegovina in 2004 and the Aid flow (current US$) in Zambia in 2008?
Your answer should be compact. -5.63e+07. What is the difference between the Aid flow (current US$) of Liberia in 2004 and the Aid flow (current US$) of Zambia in 2008?
Offer a very short reply. -6.16e+07. What is the difference between the Aid flow (current US$) in Bolivia in 2005 and the Aid flow (current US$) in Bosnia and Herzegovina in 2006?
Ensure brevity in your answer.  -1.53e+07. What is the difference between the Aid flow (current US$) of Bolivia in 2005 and the Aid flow (current US$) of Liberia in 2006?
Provide a short and direct response. -5.24e+06. What is the difference between the Aid flow (current US$) of Bolivia in 2005 and the Aid flow (current US$) of Zambia in 2006?
Make the answer very short. -6.25e+07. What is the difference between the Aid flow (current US$) in Bosnia and Herzegovina in 2005 and the Aid flow (current US$) in Liberia in 2006?
Make the answer very short. 8.75e+06. What is the difference between the Aid flow (current US$) of Bosnia and Herzegovina in 2005 and the Aid flow (current US$) of Zambia in 2006?
Provide a succinct answer. -4.85e+07. What is the difference between the Aid flow (current US$) in Liberia in 2005 and the Aid flow (current US$) in Zambia in 2006?
Give a very brief answer. -5.91e+07. What is the difference between the Aid flow (current US$) of Bolivia in 2005 and the Aid flow (current US$) of Bosnia and Herzegovina in 2007?
Offer a terse response. -1.37e+07. What is the difference between the Aid flow (current US$) in Bolivia in 2005 and the Aid flow (current US$) in Liberia in 2007?
Give a very brief answer. -2.45e+07. What is the difference between the Aid flow (current US$) in Bolivia in 2005 and the Aid flow (current US$) in Zambia in 2007?
Your response must be concise. -7.07e+07. What is the difference between the Aid flow (current US$) of Bosnia and Herzegovina in 2005 and the Aid flow (current US$) of Liberia in 2007?
Make the answer very short. -1.05e+07. What is the difference between the Aid flow (current US$) of Bosnia and Herzegovina in 2005 and the Aid flow (current US$) of Zambia in 2007?
Keep it short and to the point. -5.67e+07. What is the difference between the Aid flow (current US$) in Liberia in 2005 and the Aid flow (current US$) in Zambia in 2007?
Provide a succinct answer. -6.73e+07. What is the difference between the Aid flow (current US$) of Bolivia in 2005 and the Aid flow (current US$) of Bosnia and Herzegovina in 2008?
Provide a short and direct response. -1.53e+07. What is the difference between the Aid flow (current US$) in Bolivia in 2005 and the Aid flow (current US$) in Liberia in 2008?
Keep it short and to the point. -3.01e+07. What is the difference between the Aid flow (current US$) in Bolivia in 2005 and the Aid flow (current US$) in Zambia in 2008?
Make the answer very short. -6.96e+07. What is the difference between the Aid flow (current US$) of Bosnia and Herzegovina in 2005 and the Aid flow (current US$) of Liberia in 2008?
Give a very brief answer. -1.62e+07. What is the difference between the Aid flow (current US$) in Bosnia and Herzegovina in 2005 and the Aid flow (current US$) in Zambia in 2008?
Your response must be concise. -5.56e+07. What is the difference between the Aid flow (current US$) in Liberia in 2005 and the Aid flow (current US$) in Zambia in 2008?
Make the answer very short. -6.61e+07. What is the difference between the Aid flow (current US$) in Bolivia in 2006 and the Aid flow (current US$) in Bosnia and Herzegovina in 2007?
Keep it short and to the point. -1.37e+07. What is the difference between the Aid flow (current US$) of Bolivia in 2006 and the Aid flow (current US$) of Liberia in 2007?
Offer a very short reply. -2.45e+07. What is the difference between the Aid flow (current US$) in Bolivia in 2006 and the Aid flow (current US$) in Zambia in 2007?
Offer a terse response. -7.08e+07. What is the difference between the Aid flow (current US$) of Bosnia and Herzegovina in 2006 and the Aid flow (current US$) of Liberia in 2007?
Your response must be concise. -9.16e+06. What is the difference between the Aid flow (current US$) of Bosnia and Herzegovina in 2006 and the Aid flow (current US$) of Zambia in 2007?
Give a very brief answer. -5.54e+07. What is the difference between the Aid flow (current US$) of Liberia in 2006 and the Aid flow (current US$) of Zambia in 2007?
Your answer should be compact. -6.55e+07. What is the difference between the Aid flow (current US$) in Bolivia in 2006 and the Aid flow (current US$) in Bosnia and Herzegovina in 2008?
Your response must be concise. -1.54e+07. What is the difference between the Aid flow (current US$) of Bolivia in 2006 and the Aid flow (current US$) of Liberia in 2008?
Provide a succinct answer. -3.02e+07. What is the difference between the Aid flow (current US$) in Bolivia in 2006 and the Aid flow (current US$) in Zambia in 2008?
Offer a terse response. -6.96e+07. What is the difference between the Aid flow (current US$) of Bosnia and Herzegovina in 2006 and the Aid flow (current US$) of Liberia in 2008?
Ensure brevity in your answer.  -1.48e+07. What is the difference between the Aid flow (current US$) of Bosnia and Herzegovina in 2006 and the Aid flow (current US$) of Zambia in 2008?
Your response must be concise. -5.43e+07. What is the difference between the Aid flow (current US$) in Liberia in 2006 and the Aid flow (current US$) in Zambia in 2008?
Offer a terse response. -6.43e+07. What is the difference between the Aid flow (current US$) of Bolivia in 2007 and the Aid flow (current US$) of Bosnia and Herzegovina in 2008?
Your response must be concise. -1.39e+07. What is the difference between the Aid flow (current US$) in Bolivia in 2007 and the Aid flow (current US$) in Liberia in 2008?
Your response must be concise. -2.88e+07. What is the difference between the Aid flow (current US$) in Bolivia in 2007 and the Aid flow (current US$) in Zambia in 2008?
Give a very brief answer. -6.82e+07. What is the difference between the Aid flow (current US$) in Bosnia and Herzegovina in 2007 and the Aid flow (current US$) in Liberia in 2008?
Keep it short and to the point. -1.65e+07. What is the difference between the Aid flow (current US$) of Bosnia and Herzegovina in 2007 and the Aid flow (current US$) of Zambia in 2008?
Offer a very short reply. -5.59e+07. What is the difference between the Aid flow (current US$) of Liberia in 2007 and the Aid flow (current US$) of Zambia in 2008?
Ensure brevity in your answer.  -4.51e+07. What is the average Aid flow (current US$) in Bolivia per year?
Your answer should be very brief. 4.06e+06. What is the average Aid flow (current US$) of Bosnia and Herzegovina per year?
Keep it short and to the point. 1.91e+07. What is the average Aid flow (current US$) in Liberia per year?
Offer a terse response. 1.27e+07. What is the average Aid flow (current US$) of Zambia per year?
Your response must be concise. 4.82e+07. In the year 2001, what is the difference between the Aid flow (current US$) in Bolivia and Aid flow (current US$) in Bosnia and Herzegovina?
Your response must be concise. -1.36e+07. In the year 2001, what is the difference between the Aid flow (current US$) in Bolivia and Aid flow (current US$) in Liberia?
Give a very brief answer. 2.57e+06. In the year 2001, what is the difference between the Aid flow (current US$) in Bolivia and Aid flow (current US$) in Zambia?
Provide a short and direct response. -1.76e+07. In the year 2001, what is the difference between the Aid flow (current US$) in Bosnia and Herzegovina and Aid flow (current US$) in Liberia?
Your response must be concise. 1.62e+07. In the year 2001, what is the difference between the Aid flow (current US$) of Bosnia and Herzegovina and Aid flow (current US$) of Zambia?
Your answer should be compact. -3.94e+06. In the year 2001, what is the difference between the Aid flow (current US$) of Liberia and Aid flow (current US$) of Zambia?
Your response must be concise. -2.02e+07. In the year 2002, what is the difference between the Aid flow (current US$) of Bolivia and Aid flow (current US$) of Bosnia and Herzegovina?
Your answer should be compact. -2.05e+07. In the year 2002, what is the difference between the Aid flow (current US$) in Bolivia and Aid flow (current US$) in Liberia?
Offer a terse response. 1.35e+06. In the year 2002, what is the difference between the Aid flow (current US$) of Bolivia and Aid flow (current US$) of Zambia?
Keep it short and to the point. -2.58e+07. In the year 2002, what is the difference between the Aid flow (current US$) of Bosnia and Herzegovina and Aid flow (current US$) of Liberia?
Your answer should be compact. 2.19e+07. In the year 2002, what is the difference between the Aid flow (current US$) of Bosnia and Herzegovina and Aid flow (current US$) of Zambia?
Give a very brief answer. -5.22e+06. In the year 2002, what is the difference between the Aid flow (current US$) in Liberia and Aid flow (current US$) in Zambia?
Offer a very short reply. -2.71e+07. In the year 2003, what is the difference between the Aid flow (current US$) in Bolivia and Aid flow (current US$) in Bosnia and Herzegovina?
Make the answer very short. -1.78e+07. In the year 2003, what is the difference between the Aid flow (current US$) of Bolivia and Aid flow (current US$) of Liberia?
Provide a short and direct response. -5.19e+06. In the year 2003, what is the difference between the Aid flow (current US$) of Bolivia and Aid flow (current US$) of Zambia?
Your response must be concise. -3.18e+07. In the year 2003, what is the difference between the Aid flow (current US$) of Bosnia and Herzegovina and Aid flow (current US$) of Liberia?
Provide a succinct answer. 1.26e+07. In the year 2003, what is the difference between the Aid flow (current US$) in Bosnia and Herzegovina and Aid flow (current US$) in Zambia?
Offer a very short reply. -1.40e+07. In the year 2003, what is the difference between the Aid flow (current US$) of Liberia and Aid flow (current US$) of Zambia?
Your answer should be very brief. -2.66e+07. In the year 2004, what is the difference between the Aid flow (current US$) in Bolivia and Aid flow (current US$) in Bosnia and Herzegovina?
Offer a very short reply. -1.36e+07. In the year 2004, what is the difference between the Aid flow (current US$) in Bolivia and Aid flow (current US$) in Liberia?
Keep it short and to the point. -8.26e+06. In the year 2004, what is the difference between the Aid flow (current US$) of Bolivia and Aid flow (current US$) of Zambia?
Ensure brevity in your answer.  -3.40e+07. In the year 2004, what is the difference between the Aid flow (current US$) in Bosnia and Herzegovina and Aid flow (current US$) in Liberia?
Your answer should be very brief. 5.37e+06. In the year 2004, what is the difference between the Aid flow (current US$) of Bosnia and Herzegovina and Aid flow (current US$) of Zambia?
Offer a very short reply. -2.04e+07. In the year 2004, what is the difference between the Aid flow (current US$) of Liberia and Aid flow (current US$) of Zambia?
Your response must be concise. -2.57e+07. In the year 2005, what is the difference between the Aid flow (current US$) of Bolivia and Aid flow (current US$) of Bosnia and Herzegovina?
Make the answer very short. -1.40e+07. In the year 2005, what is the difference between the Aid flow (current US$) of Bolivia and Aid flow (current US$) of Liberia?
Provide a succinct answer. -3.44e+06. In the year 2005, what is the difference between the Aid flow (current US$) in Bolivia and Aid flow (current US$) in Zambia?
Ensure brevity in your answer.  -4.53e+07. In the year 2005, what is the difference between the Aid flow (current US$) of Bosnia and Herzegovina and Aid flow (current US$) of Liberia?
Provide a short and direct response. 1.06e+07. In the year 2005, what is the difference between the Aid flow (current US$) in Bosnia and Herzegovina and Aid flow (current US$) in Zambia?
Offer a terse response. -3.13e+07. In the year 2005, what is the difference between the Aid flow (current US$) in Liberia and Aid flow (current US$) in Zambia?
Your answer should be very brief. -4.18e+07. In the year 2006, what is the difference between the Aid flow (current US$) in Bolivia and Aid flow (current US$) in Bosnia and Herzegovina?
Offer a terse response. -1.54e+07. In the year 2006, what is the difference between the Aid flow (current US$) of Bolivia and Aid flow (current US$) of Liberia?
Provide a succinct answer. -5.30e+06. In the year 2006, what is the difference between the Aid flow (current US$) in Bolivia and Aid flow (current US$) in Zambia?
Keep it short and to the point. -6.26e+07. In the year 2006, what is the difference between the Aid flow (current US$) of Bosnia and Herzegovina and Aid flow (current US$) of Liberia?
Your answer should be very brief. 1.01e+07. In the year 2006, what is the difference between the Aid flow (current US$) of Bosnia and Herzegovina and Aid flow (current US$) of Zambia?
Ensure brevity in your answer.  -4.72e+07. In the year 2006, what is the difference between the Aid flow (current US$) of Liberia and Aid flow (current US$) of Zambia?
Provide a succinct answer. -5.73e+07. In the year 2007, what is the difference between the Aid flow (current US$) of Bolivia and Aid flow (current US$) of Bosnia and Herzegovina?
Keep it short and to the point. -1.23e+07. In the year 2007, what is the difference between the Aid flow (current US$) in Bolivia and Aid flow (current US$) in Liberia?
Ensure brevity in your answer.  -2.31e+07. In the year 2007, what is the difference between the Aid flow (current US$) in Bolivia and Aid flow (current US$) in Zambia?
Provide a short and direct response. -6.94e+07. In the year 2007, what is the difference between the Aid flow (current US$) in Bosnia and Herzegovina and Aid flow (current US$) in Liberia?
Your answer should be compact. -1.08e+07. In the year 2007, what is the difference between the Aid flow (current US$) in Bosnia and Herzegovina and Aid flow (current US$) in Zambia?
Ensure brevity in your answer.  -5.70e+07. In the year 2007, what is the difference between the Aid flow (current US$) of Liberia and Aid flow (current US$) of Zambia?
Provide a succinct answer. -4.62e+07. In the year 2008, what is the difference between the Aid flow (current US$) in Bolivia and Aid flow (current US$) in Bosnia and Herzegovina?
Your answer should be very brief. -1.26e+07. In the year 2008, what is the difference between the Aid flow (current US$) in Bolivia and Aid flow (current US$) in Liberia?
Make the answer very short. -2.74e+07. In the year 2008, what is the difference between the Aid flow (current US$) of Bolivia and Aid flow (current US$) of Zambia?
Your response must be concise. -6.69e+07. In the year 2008, what is the difference between the Aid flow (current US$) of Bosnia and Herzegovina and Aid flow (current US$) of Liberia?
Your answer should be very brief. -1.48e+07. In the year 2008, what is the difference between the Aid flow (current US$) in Bosnia and Herzegovina and Aid flow (current US$) in Zambia?
Your answer should be compact. -5.43e+07. In the year 2008, what is the difference between the Aid flow (current US$) of Liberia and Aid flow (current US$) of Zambia?
Ensure brevity in your answer.  -3.94e+07. What is the ratio of the Aid flow (current US$) in Bolivia in 2001 to that in 2002?
Make the answer very short. 0.98. What is the ratio of the Aid flow (current US$) in Bosnia and Herzegovina in 2001 to that in 2002?
Your answer should be very brief. 0.71. What is the ratio of the Aid flow (current US$) in Liberia in 2001 to that in 2002?
Ensure brevity in your answer.  0.34. What is the ratio of the Aid flow (current US$) in Zambia in 2001 to that in 2002?
Offer a very short reply. 0.72. What is the ratio of the Aid flow (current US$) of Bolivia in 2001 to that in 2003?
Offer a very short reply. 0.85. What is the ratio of the Aid flow (current US$) in Bosnia and Herzegovina in 2001 to that in 2003?
Provide a short and direct response. 0.78. What is the ratio of the Aid flow (current US$) in Liberia in 2001 to that in 2003?
Offer a very short reply. 0.07. What is the ratio of the Aid flow (current US$) of Zambia in 2001 to that in 2003?
Give a very brief answer. 0.58. What is the ratio of the Aid flow (current US$) in Bolivia in 2001 to that in 2004?
Offer a terse response. 0.95. What is the ratio of the Aid flow (current US$) in Liberia in 2001 to that in 2004?
Make the answer very short. 0.06. What is the ratio of the Aid flow (current US$) in Zambia in 2001 to that in 2004?
Offer a very short reply. 0.56. What is the ratio of the Aid flow (current US$) of Bolivia in 2001 to that in 2005?
Give a very brief answer. 0.87. What is the ratio of the Aid flow (current US$) in Bosnia and Herzegovina in 2001 to that in 2005?
Provide a short and direct response. 0.95. What is the ratio of the Aid flow (current US$) in Liberia in 2001 to that in 2005?
Your answer should be compact. 0.09. What is the ratio of the Aid flow (current US$) in Zambia in 2001 to that in 2005?
Offer a very short reply. 0.42. What is the ratio of the Aid flow (current US$) in Bolivia in 2001 to that in 2006?
Your response must be concise. 0.88. What is the ratio of the Aid flow (current US$) in Bosnia and Herzegovina in 2001 to that in 2006?
Ensure brevity in your answer.  0.89. What is the ratio of the Aid flow (current US$) in Liberia in 2001 to that in 2006?
Your response must be concise. 0.07. What is the ratio of the Aid flow (current US$) in Zambia in 2001 to that in 2006?
Offer a terse response. 0.31. What is the ratio of the Aid flow (current US$) in Bolivia in 2001 to that in 2007?
Your response must be concise. 0.64. What is the ratio of the Aid flow (current US$) in Bosnia and Herzegovina in 2001 to that in 2007?
Give a very brief answer. 0.97. What is the ratio of the Aid flow (current US$) of Liberia in 2001 to that in 2007?
Keep it short and to the point. 0.02. What is the ratio of the Aid flow (current US$) in Zambia in 2001 to that in 2007?
Make the answer very short. 0.28. What is the ratio of the Aid flow (current US$) of Bolivia in 2001 to that in 2008?
Keep it short and to the point. 0.5. What is the ratio of the Aid flow (current US$) in Bosnia and Herzegovina in 2001 to that in 2008?
Offer a terse response. 0.89. What is the ratio of the Aid flow (current US$) of Liberia in 2001 to that in 2008?
Offer a very short reply. 0.02. What is the ratio of the Aid flow (current US$) of Zambia in 2001 to that in 2008?
Your answer should be very brief. 0.28. What is the ratio of the Aid flow (current US$) of Bolivia in 2002 to that in 2003?
Offer a very short reply. 0.87. What is the ratio of the Aid flow (current US$) in Bosnia and Herzegovina in 2002 to that in 2003?
Offer a very short reply. 1.1. What is the ratio of the Aid flow (current US$) in Liberia in 2002 to that in 2003?
Offer a very short reply. 0.22. What is the ratio of the Aid flow (current US$) of Zambia in 2002 to that in 2003?
Give a very brief answer. 0.82. What is the ratio of the Aid flow (current US$) in Bolivia in 2002 to that in 2004?
Make the answer very short. 0.97. What is the ratio of the Aid flow (current US$) of Bosnia and Herzegovina in 2002 to that in 2004?
Provide a succinct answer. 1.4. What is the ratio of the Aid flow (current US$) of Liberia in 2002 to that in 2004?
Your answer should be very brief. 0.17. What is the ratio of the Aid flow (current US$) of Zambia in 2002 to that in 2004?
Keep it short and to the point. 0.78. What is the ratio of the Aid flow (current US$) of Bolivia in 2002 to that in 2005?
Provide a short and direct response. 0.89. What is the ratio of the Aid flow (current US$) of Bosnia and Herzegovina in 2002 to that in 2005?
Make the answer very short. 1.35. What is the ratio of the Aid flow (current US$) in Liberia in 2002 to that in 2005?
Ensure brevity in your answer.  0.27. What is the ratio of the Aid flow (current US$) of Zambia in 2002 to that in 2005?
Offer a terse response. 0.59. What is the ratio of the Aid flow (current US$) of Bolivia in 2002 to that in 2006?
Offer a very short reply. 0.9. What is the ratio of the Aid flow (current US$) in Bosnia and Herzegovina in 2002 to that in 2006?
Keep it short and to the point. 1.25. What is the ratio of the Aid flow (current US$) in Liberia in 2002 to that in 2006?
Make the answer very short. 0.22. What is the ratio of the Aid flow (current US$) in Zambia in 2002 to that in 2006?
Provide a succinct answer. 0.44. What is the ratio of the Aid flow (current US$) in Bolivia in 2002 to that in 2007?
Your answer should be very brief. 0.65. What is the ratio of the Aid flow (current US$) of Bosnia and Herzegovina in 2002 to that in 2007?
Your response must be concise. 1.37. What is the ratio of the Aid flow (current US$) of Liberia in 2002 to that in 2007?
Your answer should be very brief. 0.07. What is the ratio of the Aid flow (current US$) of Zambia in 2002 to that in 2007?
Give a very brief answer. 0.39. What is the ratio of the Aid flow (current US$) of Bolivia in 2002 to that in 2008?
Provide a succinct answer. 0.51. What is the ratio of the Aid flow (current US$) in Bosnia and Herzegovina in 2002 to that in 2008?
Your answer should be compact. 1.25. What is the ratio of the Aid flow (current US$) in Liberia in 2002 to that in 2008?
Make the answer very short. 0.06. What is the ratio of the Aid flow (current US$) in Zambia in 2002 to that in 2008?
Ensure brevity in your answer.  0.4. What is the ratio of the Aid flow (current US$) of Bolivia in 2003 to that in 2004?
Your response must be concise. 1.12. What is the ratio of the Aid flow (current US$) in Bosnia and Herzegovina in 2003 to that in 2004?
Your answer should be very brief. 1.27. What is the ratio of the Aid flow (current US$) of Liberia in 2003 to that in 2004?
Your response must be concise. 0.77. What is the ratio of the Aid flow (current US$) of Zambia in 2003 to that in 2004?
Your answer should be compact. 0.95. What is the ratio of the Aid flow (current US$) of Bolivia in 2003 to that in 2005?
Your answer should be very brief. 1.02. What is the ratio of the Aid flow (current US$) of Bosnia and Herzegovina in 2003 to that in 2005?
Provide a short and direct response. 1.22. What is the ratio of the Aid flow (current US$) in Liberia in 2003 to that in 2005?
Your response must be concise. 1.26. What is the ratio of the Aid flow (current US$) of Zambia in 2003 to that in 2005?
Keep it short and to the point. 0.73. What is the ratio of the Aid flow (current US$) in Bolivia in 2003 to that in 2006?
Your response must be concise. 1.04. What is the ratio of the Aid flow (current US$) in Bosnia and Herzegovina in 2003 to that in 2006?
Offer a terse response. 1.14. What is the ratio of the Aid flow (current US$) of Zambia in 2003 to that in 2006?
Ensure brevity in your answer.  0.54. What is the ratio of the Aid flow (current US$) in Bolivia in 2003 to that in 2007?
Provide a short and direct response. 0.75. What is the ratio of the Aid flow (current US$) of Bosnia and Herzegovina in 2003 to that in 2007?
Make the answer very short. 1.24. What is the ratio of the Aid flow (current US$) of Liberia in 2003 to that in 2007?
Offer a very short reply. 0.32. What is the ratio of the Aid flow (current US$) in Zambia in 2003 to that in 2007?
Keep it short and to the point. 0.48. What is the ratio of the Aid flow (current US$) of Bolivia in 2003 to that in 2008?
Your answer should be compact. 0.59. What is the ratio of the Aid flow (current US$) in Bosnia and Herzegovina in 2003 to that in 2008?
Keep it short and to the point. 1.14. What is the ratio of the Aid flow (current US$) of Liberia in 2003 to that in 2008?
Ensure brevity in your answer.  0.27. What is the ratio of the Aid flow (current US$) of Zambia in 2003 to that in 2008?
Your answer should be compact. 0.49. What is the ratio of the Aid flow (current US$) of Bolivia in 2004 to that in 2005?
Provide a succinct answer. 0.91. What is the ratio of the Aid flow (current US$) in Bosnia and Herzegovina in 2004 to that in 2005?
Your answer should be compact. 0.96. What is the ratio of the Aid flow (current US$) in Liberia in 2004 to that in 2005?
Offer a very short reply. 1.63. What is the ratio of the Aid flow (current US$) in Zambia in 2004 to that in 2005?
Your answer should be compact. 0.76. What is the ratio of the Aid flow (current US$) in Bolivia in 2004 to that in 2006?
Offer a terse response. 0.93. What is the ratio of the Aid flow (current US$) in Bosnia and Herzegovina in 2004 to that in 2006?
Provide a succinct answer. 0.89. What is the ratio of the Aid flow (current US$) of Liberia in 2004 to that in 2006?
Ensure brevity in your answer.  1.3. What is the ratio of the Aid flow (current US$) in Zambia in 2004 to that in 2006?
Offer a terse response. 0.56. What is the ratio of the Aid flow (current US$) of Bolivia in 2004 to that in 2007?
Keep it short and to the point. 0.67. What is the ratio of the Aid flow (current US$) in Bosnia and Herzegovina in 2004 to that in 2007?
Provide a short and direct response. 0.98. What is the ratio of the Aid flow (current US$) in Liberia in 2004 to that in 2007?
Provide a succinct answer. 0.41. What is the ratio of the Aid flow (current US$) of Zambia in 2004 to that in 2007?
Offer a terse response. 0.5. What is the ratio of the Aid flow (current US$) of Bolivia in 2004 to that in 2008?
Your answer should be very brief. 0.53. What is the ratio of the Aid flow (current US$) of Bosnia and Herzegovina in 2004 to that in 2008?
Offer a terse response. 0.89. What is the ratio of the Aid flow (current US$) in Liberia in 2004 to that in 2008?
Your answer should be compact. 0.34. What is the ratio of the Aid flow (current US$) in Zambia in 2004 to that in 2008?
Ensure brevity in your answer.  0.51. What is the ratio of the Aid flow (current US$) in Bolivia in 2005 to that in 2006?
Keep it short and to the point. 1.02. What is the ratio of the Aid flow (current US$) of Bosnia and Herzegovina in 2005 to that in 2006?
Your response must be concise. 0.93. What is the ratio of the Aid flow (current US$) of Liberia in 2005 to that in 2006?
Your response must be concise. 0.8. What is the ratio of the Aid flow (current US$) in Zambia in 2005 to that in 2006?
Ensure brevity in your answer.  0.74. What is the ratio of the Aid flow (current US$) of Bolivia in 2005 to that in 2007?
Ensure brevity in your answer.  0.73. What is the ratio of the Aid flow (current US$) of Bosnia and Herzegovina in 2005 to that in 2007?
Offer a very short reply. 1.02. What is the ratio of the Aid flow (current US$) of Liberia in 2005 to that in 2007?
Make the answer very short. 0.25. What is the ratio of the Aid flow (current US$) of Zambia in 2005 to that in 2007?
Ensure brevity in your answer.  0.66. What is the ratio of the Aid flow (current US$) of Bolivia in 2005 to that in 2008?
Make the answer very short. 0.58. What is the ratio of the Aid flow (current US$) in Bosnia and Herzegovina in 2005 to that in 2008?
Provide a short and direct response. 0.93. What is the ratio of the Aid flow (current US$) in Liberia in 2005 to that in 2008?
Make the answer very short. 0.21. What is the ratio of the Aid flow (current US$) of Zambia in 2005 to that in 2008?
Offer a terse response. 0.67. What is the ratio of the Aid flow (current US$) in Bolivia in 2006 to that in 2007?
Provide a succinct answer. 0.72. What is the ratio of the Aid flow (current US$) of Bosnia and Herzegovina in 2006 to that in 2007?
Provide a short and direct response. 1.09. What is the ratio of the Aid flow (current US$) of Liberia in 2006 to that in 2007?
Your answer should be very brief. 0.32. What is the ratio of the Aid flow (current US$) in Zambia in 2006 to that in 2007?
Give a very brief answer. 0.89. What is the ratio of the Aid flow (current US$) of Bolivia in 2006 to that in 2008?
Your answer should be very brief. 0.57. What is the ratio of the Aid flow (current US$) in Liberia in 2006 to that in 2008?
Make the answer very short. 0.26. What is the ratio of the Aid flow (current US$) in Zambia in 2006 to that in 2008?
Ensure brevity in your answer.  0.9. What is the ratio of the Aid flow (current US$) of Bolivia in 2007 to that in 2008?
Your answer should be very brief. 0.79. What is the ratio of the Aid flow (current US$) of Bosnia and Herzegovina in 2007 to that in 2008?
Give a very brief answer. 0.91. What is the ratio of the Aid flow (current US$) in Liberia in 2007 to that in 2008?
Your response must be concise. 0.83. What is the ratio of the Aid flow (current US$) in Zambia in 2007 to that in 2008?
Offer a terse response. 1.02. What is the difference between the highest and the second highest Aid flow (current US$) in Bolivia?
Make the answer very short. 1.34e+06. What is the difference between the highest and the second highest Aid flow (current US$) of Bosnia and Herzegovina?
Keep it short and to the point. 2.21e+06. What is the difference between the highest and the second highest Aid flow (current US$) of Liberia?
Offer a terse response. 5.67e+06. What is the difference between the highest and the second highest Aid flow (current US$) of Zambia?
Keep it short and to the point. 1.15e+06. What is the difference between the highest and the lowest Aid flow (current US$) in Bolivia?
Make the answer very short. 3.19e+06. What is the difference between the highest and the lowest Aid flow (current US$) in Bosnia and Herzegovina?
Give a very brief answer. 6.96e+06. What is the difference between the highest and the lowest Aid flow (current US$) in Liberia?
Keep it short and to the point. 3.32e+07. What is the difference between the highest and the lowest Aid flow (current US$) in Zambia?
Give a very brief answer. 5.36e+07. 